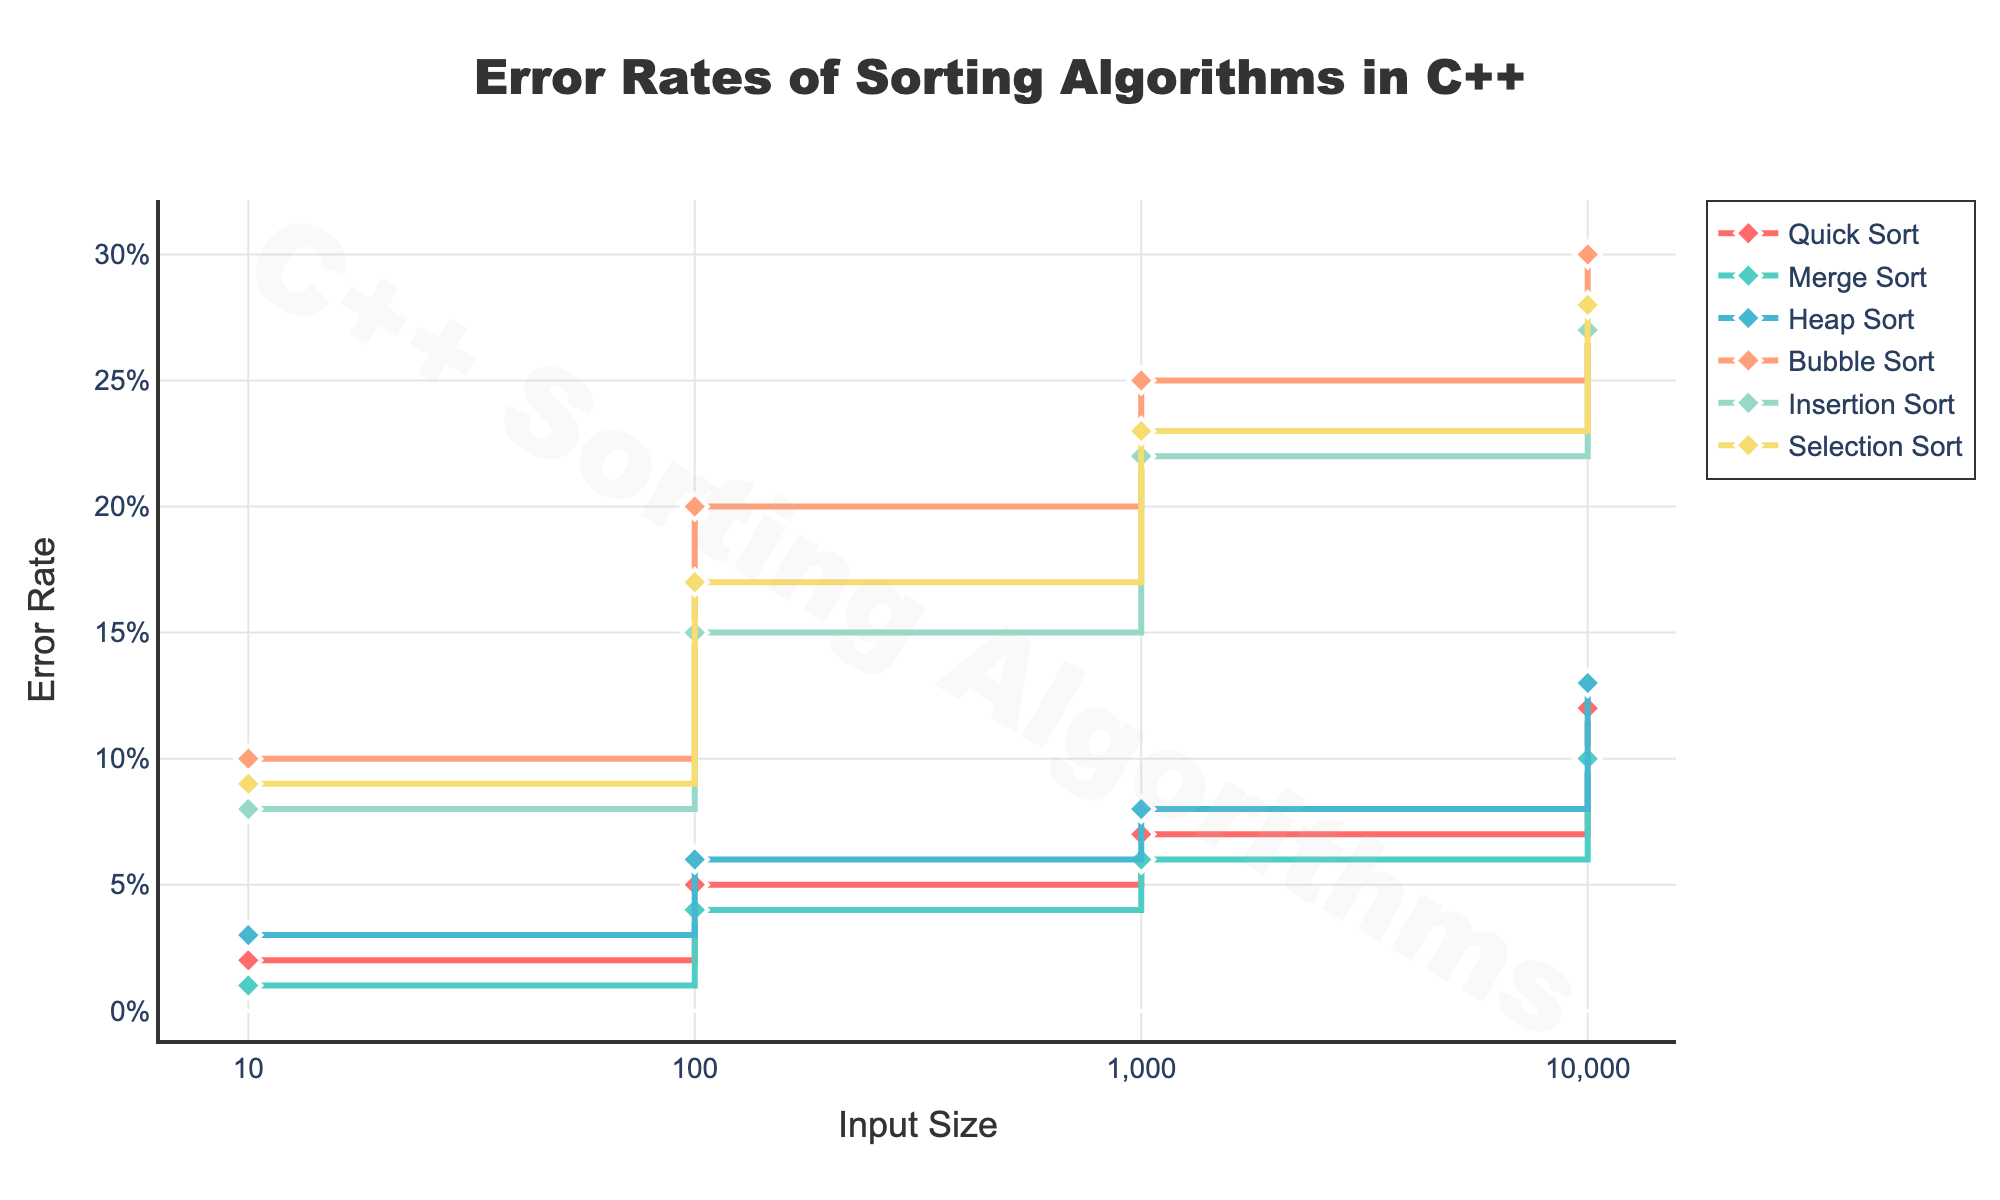What is the title of the figure? The title is located at the top of the figure, specifying the main subject of the plot. From the description, the title is "Error Rates of Sorting Algorithms in C++".
Answer: Error Rates of Sorting Algorithms in C++ What are the input sizes represented on the x-axis? The x-axis represents the input sizes, which are shown in a logarithmic scale with tick values '10', '100', '1,000', and '10,000'. This is indicated by the tick values and labels mentioned in the code.
Answer: 10, 100, 1,000, 10,000 Which sorting algorithm has the highest error rate for input size 10? By looking at input size 10 on the plot, Bubble Sort shows the highest error rate at this point compared to other algorithms.
Answer: Bubble Sort Compare the error rates of Quick Sort and Merge Sort for input size 1,000. Which one has a higher rate? At input size 1,000, Quick Sort has an error rate of 0.07, and Merge Sort has an error rate of 0.06. Therefore, Quick Sort has a higher error rate than Merge Sort for this input size.
Answer: Quick Sort What is the mechanism behind the stair-step appearance of the plot lines? The plot is a stair-step or step plot due to the 'hv' (horizontal-vertical) shape of the lines. This means the lines move horizontally to the next input size before moving vertically to the new error rate value.
Answer: Horizontal-vertical line movement Which algorithm shows the largest increase in error rate as input size increases from 10 to 10,000? Comparing the error rate changes, Bubble Sort increases from 0.10 at input size 10 to 0.30 at input size 10,000, which is the largest increase among the algorithms.
Answer: Bubble Sort For input size 10,000, which algorithm performs better (i.e., has a lower error rate): Heap Sort or Selection Sort? At input size 10,000, Heap Sort has an error rate of 0.13, and Selection Sort has an error rate of 0.28. Heap Sort performs better as it has a lower error rate.
Answer: Heap Sort Determine the average error rate for Insertion Sort techniques across all input sizes. Adding all error rates for Insertion Sort: 0.08 + 0.15 + 0.22 + 0.27 = 0.72. There are 4 data points, so the average is 0.72 / 4 = 0.18.
Answer: 0.18 Identify any two algorithms whose error rates converge or become close as input size increases to 10,000. As input size increases to 10,000, the error rates of Merge Sort (0.10) and Quick Sort (0.12) become relatively close compared to their rates at smaller input sizes.
Answer: Merge Sort and Quick Sort 